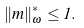<formula> <loc_0><loc_0><loc_500><loc_500>\| m \| ^ { * } _ { \omega } \leq 1 .</formula> 